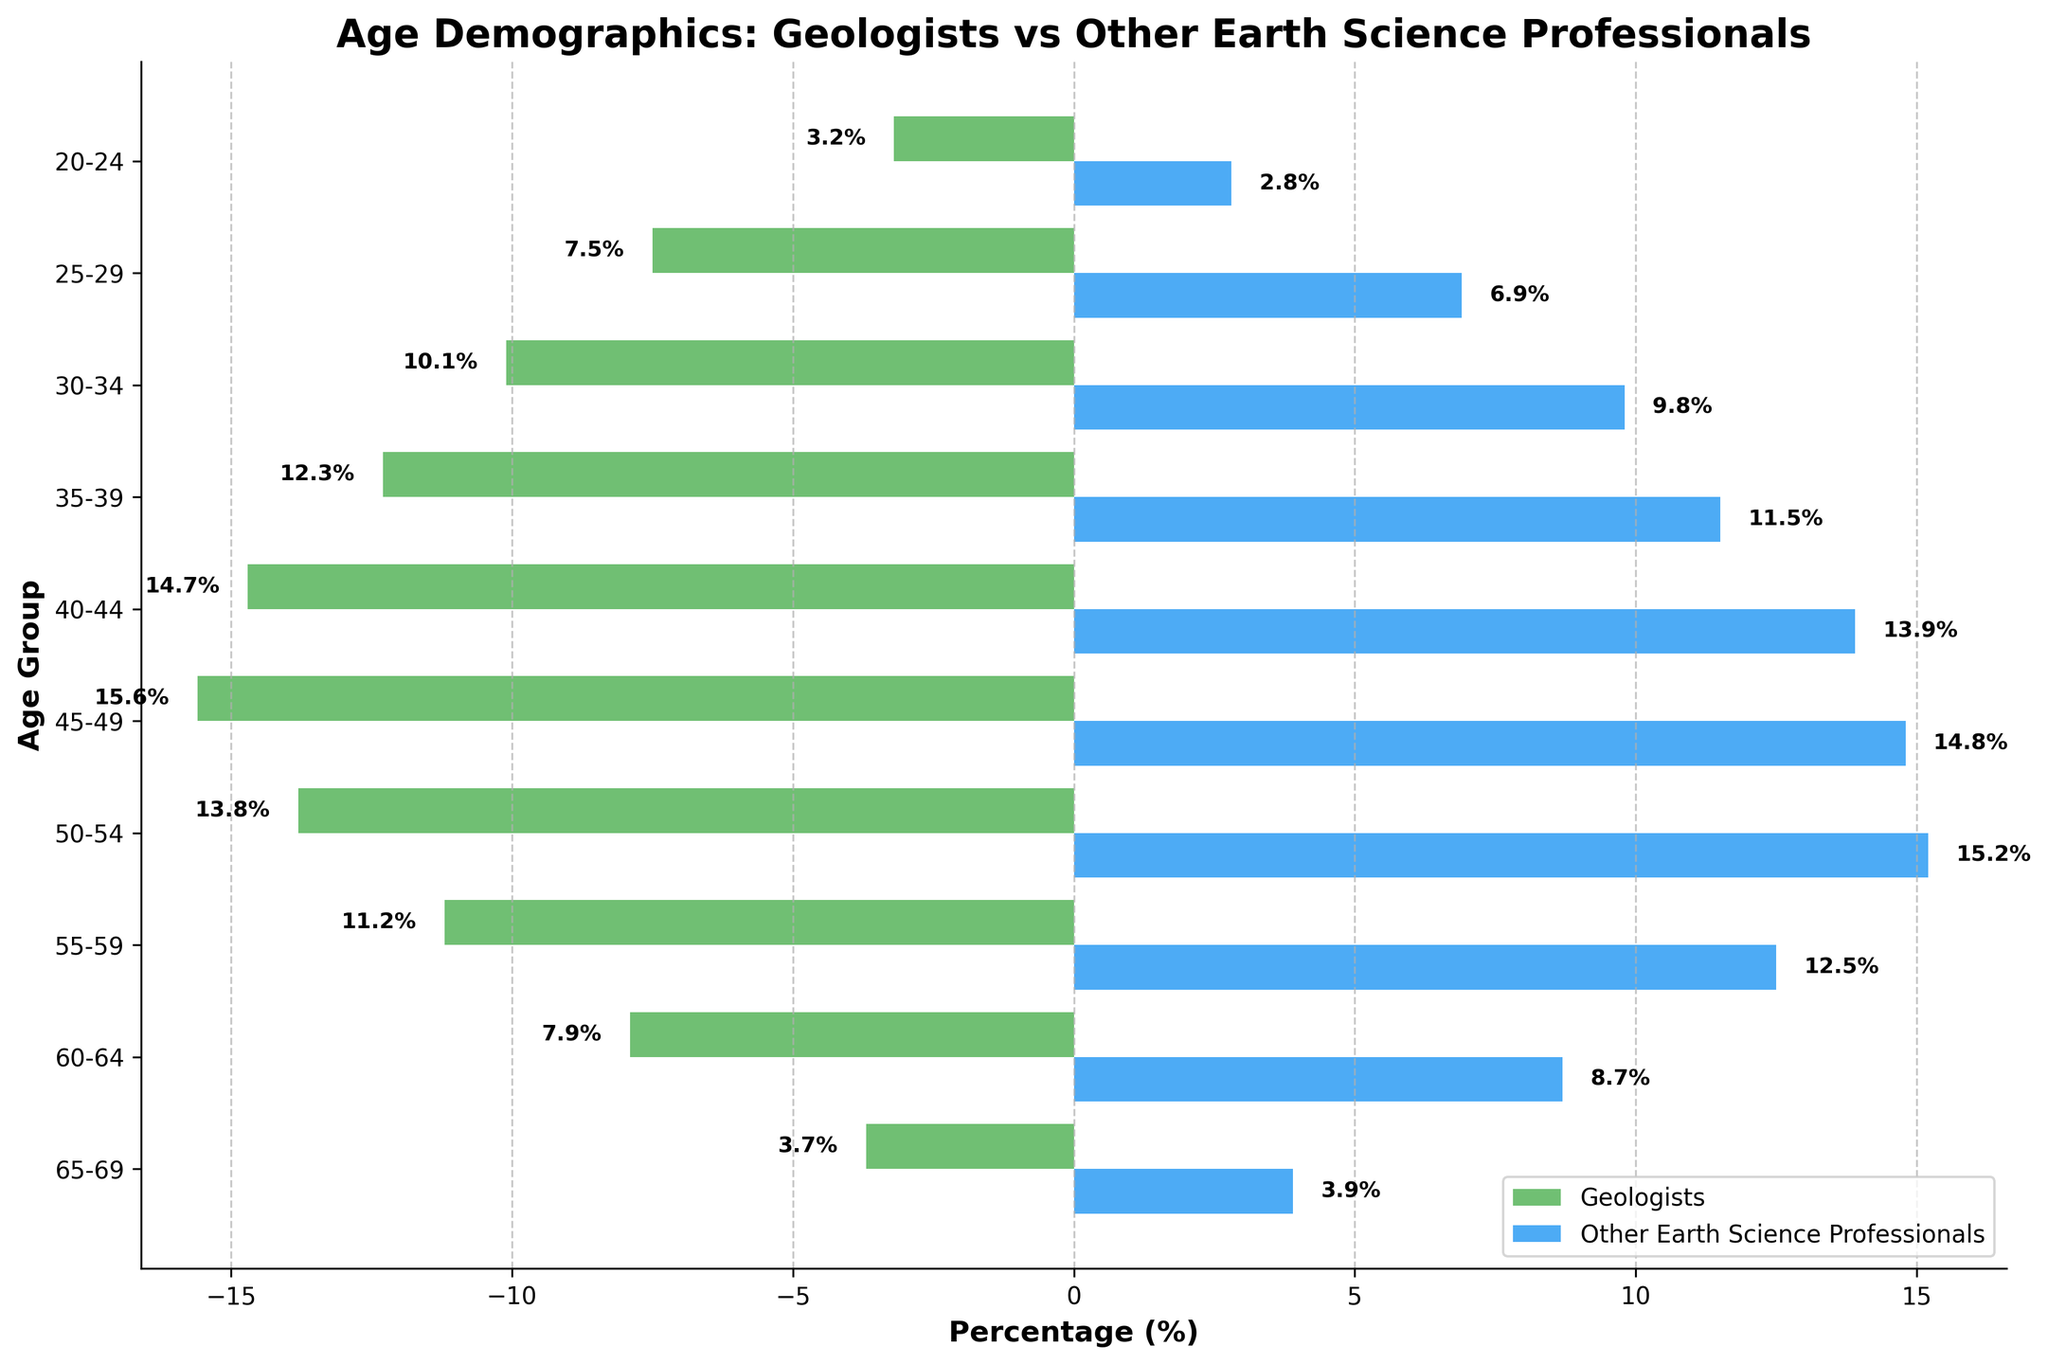What is the title of the figure? The title of the figure is mentioned at the top of the chart. It is "Age Demographics: Geologists vs Other Earth Science Professionals".
Answer: Age Demographics: Geologists vs Other Earth Science Professionals Which age group has the highest percentage of geologists? By observing the bars for geologists, the longest bar corresponds to the age group 45-49.
Answer: 45-49 How many age groups are represented in the figure? The number of age groups can be counted from the y-axis labels. There are 10 age groups in total.
Answer: 10 What is the percentage of geologists in the age group 30-34? The bar for geologists in the age group 30-34 has a label indicating 10.1%.
Answer: 10.1% Which group has a higher percentage in the age group 50-54, and by how much? The chart shows that Other Earth Science Professionals have a higher percentage (15.2%) compared to geologists (13.8%). The difference is 15.2 - 13.8 = 1.4%.
Answer: Other Earth Science Professionals, 1.4% What is the total percentage of geologists in all age groups? Sum the percentages of geologists in all age groups: 3.2 + 7.5 + 10.1 + 12.3 + 14.7 + 15.6 + 13.8 + 11.2 + 7.9 + 3.7 = 100%.
Answer: 100% How do the percentages of geologists compare to other earth science professionals in the age group 55-59? In the age group 55-59, geologists have a percentage of 11.2%, while other earth science professionals have 12.5%. Therefore, other earth science professionals have a higher percentage by 12.5 - 11.2 = 1.3%.
Answer: Other earth science professionals, 1.3% Which age group has the smallest difference between the two groups? By comparing the differences for each age group, the smallest difference is in the age group 65-69 where the difference is 3.9 - 3.7 = 0.2%.
Answer: 65-69 What’s the average percentage of geologists in the age groups 40-44 and 45-49? The percentages for geologists in the age groups 40-44 and 45-49 are 14.7% and 15.6%, respectively. The average is (14.7 + 15.6) / 2 = 15.15%.
Answer: 15.15% Is the distribution of age demographics for geologists symmetrical? A symmetrical distribution would mean that the percentages are relatively consistent across the age groups from youngest to oldest or vice versa. The given distribution is not symmetrical as there are variations with a peak at 45-49 and decreasing thereafter.
Answer: No 